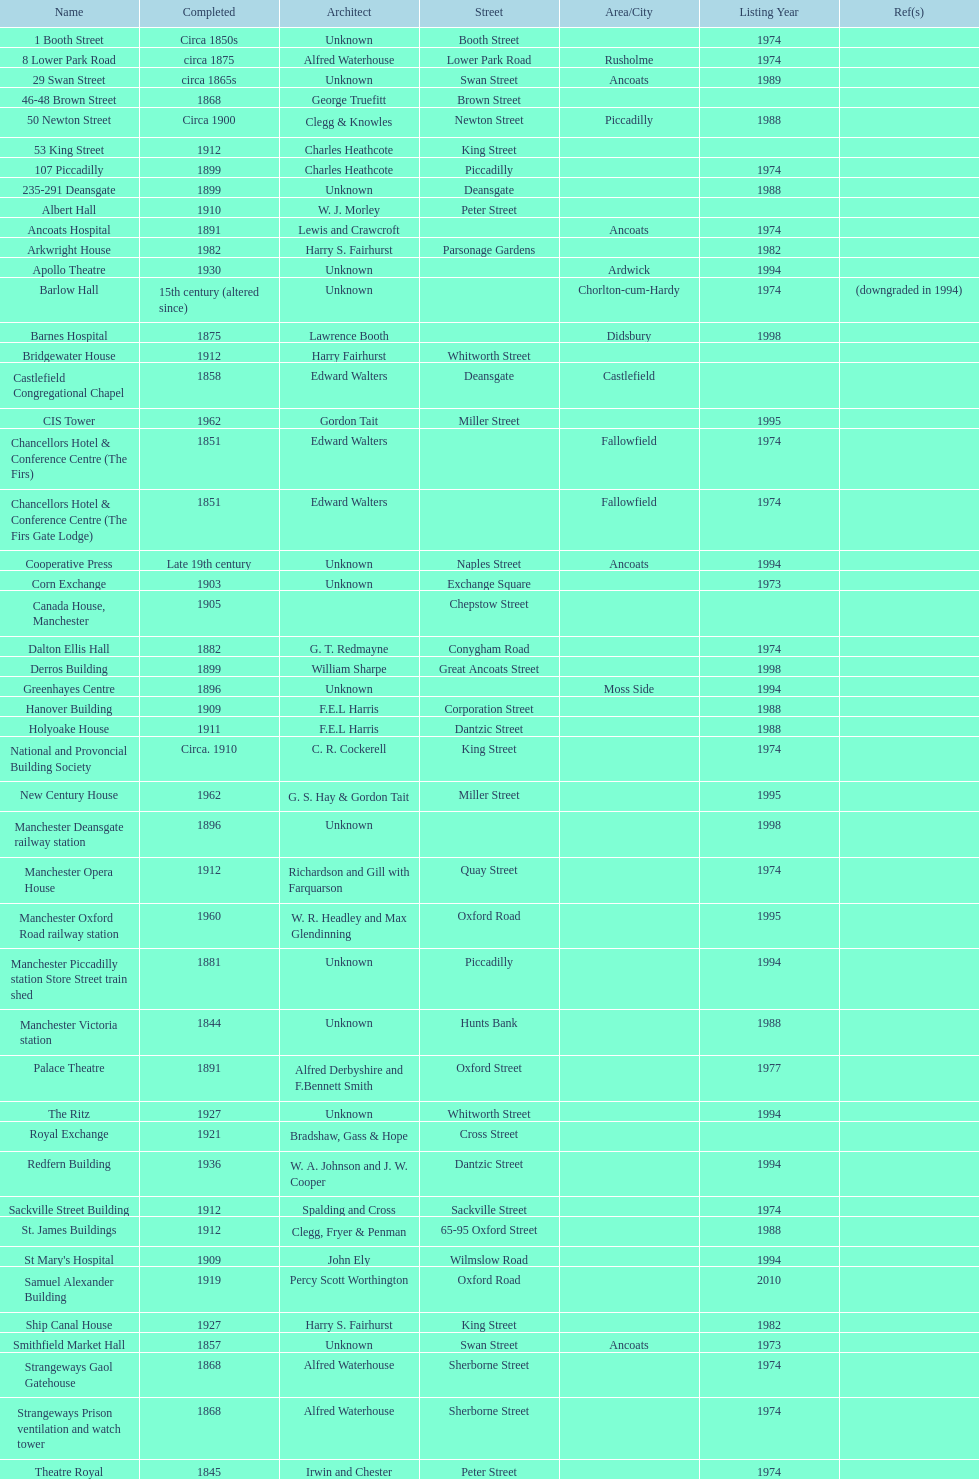What is the difference, in years, between the completion dates of 53 king street and castlefield congregational chapel? 54 years. 